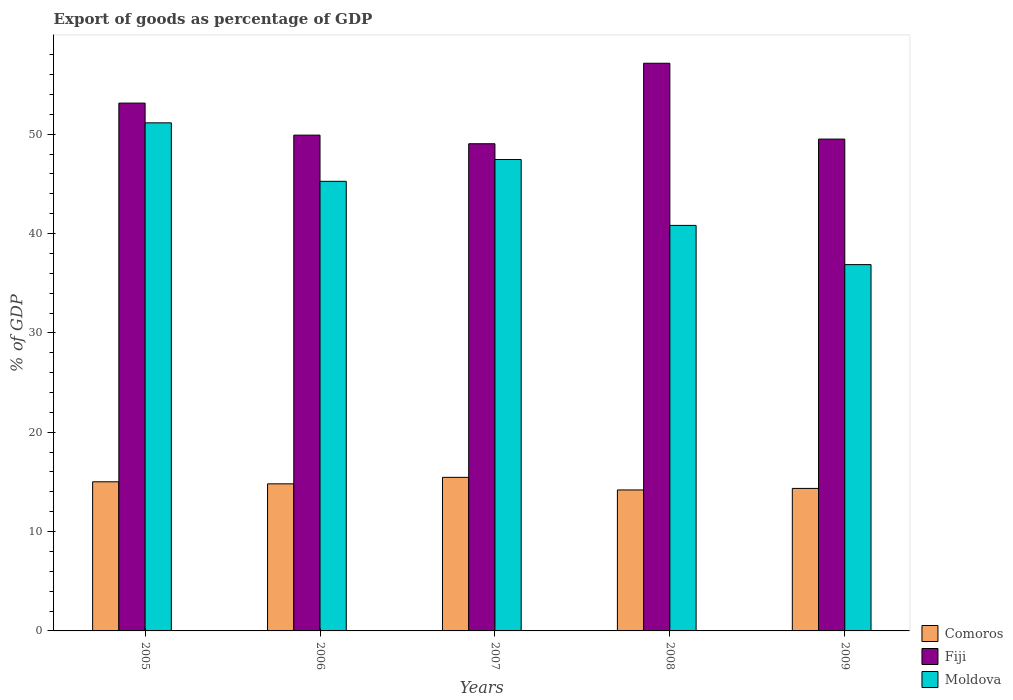Are the number of bars on each tick of the X-axis equal?
Your answer should be compact. Yes. How many bars are there on the 3rd tick from the left?
Keep it short and to the point. 3. How many bars are there on the 4th tick from the right?
Give a very brief answer. 3. What is the label of the 1st group of bars from the left?
Offer a very short reply. 2005. What is the export of goods as percentage of GDP in Moldova in 2006?
Give a very brief answer. 45.26. Across all years, what is the maximum export of goods as percentage of GDP in Comoros?
Provide a succinct answer. 15.46. Across all years, what is the minimum export of goods as percentage of GDP in Moldova?
Provide a short and direct response. 36.87. In which year was the export of goods as percentage of GDP in Moldova minimum?
Offer a very short reply. 2009. What is the total export of goods as percentage of GDP in Comoros in the graph?
Your answer should be compact. 73.81. What is the difference between the export of goods as percentage of GDP in Moldova in 2006 and that in 2009?
Your answer should be very brief. 8.38. What is the difference between the export of goods as percentage of GDP in Moldova in 2005 and the export of goods as percentage of GDP in Fiji in 2009?
Your answer should be very brief. 1.64. What is the average export of goods as percentage of GDP in Fiji per year?
Make the answer very short. 51.74. In the year 2005, what is the difference between the export of goods as percentage of GDP in Comoros and export of goods as percentage of GDP in Fiji?
Keep it short and to the point. -38.12. In how many years, is the export of goods as percentage of GDP in Moldova greater than 34 %?
Offer a very short reply. 5. What is the ratio of the export of goods as percentage of GDP in Comoros in 2007 to that in 2009?
Keep it short and to the point. 1.08. What is the difference between the highest and the second highest export of goods as percentage of GDP in Comoros?
Provide a short and direct response. 0.45. What is the difference between the highest and the lowest export of goods as percentage of GDP in Comoros?
Give a very brief answer. 1.27. In how many years, is the export of goods as percentage of GDP in Moldova greater than the average export of goods as percentage of GDP in Moldova taken over all years?
Keep it short and to the point. 3. Is the sum of the export of goods as percentage of GDP in Comoros in 2007 and 2009 greater than the maximum export of goods as percentage of GDP in Fiji across all years?
Provide a succinct answer. No. What does the 1st bar from the left in 2009 represents?
Offer a very short reply. Comoros. What does the 2nd bar from the right in 2007 represents?
Provide a succinct answer. Fiji. How many bars are there?
Offer a terse response. 15. Are all the bars in the graph horizontal?
Provide a short and direct response. No. How many years are there in the graph?
Offer a terse response. 5. What is the difference between two consecutive major ticks on the Y-axis?
Give a very brief answer. 10. Are the values on the major ticks of Y-axis written in scientific E-notation?
Make the answer very short. No. Does the graph contain any zero values?
Your response must be concise. No. How are the legend labels stacked?
Provide a succinct answer. Vertical. What is the title of the graph?
Provide a succinct answer. Export of goods as percentage of GDP. Does "United States" appear as one of the legend labels in the graph?
Give a very brief answer. No. What is the label or title of the Y-axis?
Your response must be concise. % of GDP. What is the % of GDP in Comoros in 2005?
Your answer should be very brief. 15.01. What is the % of GDP in Fiji in 2005?
Give a very brief answer. 53.13. What is the % of GDP of Moldova in 2005?
Ensure brevity in your answer.  51.14. What is the % of GDP in Comoros in 2006?
Your response must be concise. 14.8. What is the % of GDP of Fiji in 2006?
Provide a succinct answer. 49.91. What is the % of GDP in Moldova in 2006?
Offer a terse response. 45.26. What is the % of GDP in Comoros in 2007?
Offer a very short reply. 15.46. What is the % of GDP in Fiji in 2007?
Offer a terse response. 49.04. What is the % of GDP of Moldova in 2007?
Provide a succinct answer. 47.45. What is the % of GDP in Comoros in 2008?
Offer a terse response. 14.19. What is the % of GDP in Fiji in 2008?
Ensure brevity in your answer.  57.14. What is the % of GDP of Moldova in 2008?
Give a very brief answer. 40.82. What is the % of GDP in Comoros in 2009?
Your answer should be very brief. 14.34. What is the % of GDP of Fiji in 2009?
Your answer should be very brief. 49.51. What is the % of GDP in Moldova in 2009?
Your answer should be compact. 36.87. Across all years, what is the maximum % of GDP in Comoros?
Your answer should be very brief. 15.46. Across all years, what is the maximum % of GDP of Fiji?
Provide a short and direct response. 57.14. Across all years, what is the maximum % of GDP of Moldova?
Offer a terse response. 51.14. Across all years, what is the minimum % of GDP of Comoros?
Provide a short and direct response. 14.19. Across all years, what is the minimum % of GDP in Fiji?
Keep it short and to the point. 49.04. Across all years, what is the minimum % of GDP in Moldova?
Offer a very short reply. 36.87. What is the total % of GDP in Comoros in the graph?
Provide a short and direct response. 73.81. What is the total % of GDP in Fiji in the graph?
Provide a succinct answer. 258.72. What is the total % of GDP in Moldova in the graph?
Your answer should be very brief. 221.54. What is the difference between the % of GDP in Comoros in 2005 and that in 2006?
Your answer should be compact. 0.21. What is the difference between the % of GDP of Fiji in 2005 and that in 2006?
Provide a short and direct response. 3.23. What is the difference between the % of GDP of Moldova in 2005 and that in 2006?
Offer a very short reply. 5.89. What is the difference between the % of GDP of Comoros in 2005 and that in 2007?
Your answer should be very brief. -0.45. What is the difference between the % of GDP in Fiji in 2005 and that in 2007?
Keep it short and to the point. 4.09. What is the difference between the % of GDP of Moldova in 2005 and that in 2007?
Keep it short and to the point. 3.69. What is the difference between the % of GDP of Comoros in 2005 and that in 2008?
Your response must be concise. 0.82. What is the difference between the % of GDP in Fiji in 2005 and that in 2008?
Your response must be concise. -4.01. What is the difference between the % of GDP in Moldova in 2005 and that in 2008?
Offer a terse response. 10.33. What is the difference between the % of GDP in Comoros in 2005 and that in 2009?
Offer a terse response. 0.67. What is the difference between the % of GDP in Fiji in 2005 and that in 2009?
Offer a very short reply. 3.62. What is the difference between the % of GDP of Moldova in 2005 and that in 2009?
Offer a very short reply. 14.27. What is the difference between the % of GDP in Comoros in 2006 and that in 2007?
Your answer should be very brief. -0.65. What is the difference between the % of GDP of Fiji in 2006 and that in 2007?
Your answer should be compact. 0.87. What is the difference between the % of GDP in Moldova in 2006 and that in 2007?
Keep it short and to the point. -2.2. What is the difference between the % of GDP in Comoros in 2006 and that in 2008?
Keep it short and to the point. 0.61. What is the difference between the % of GDP in Fiji in 2006 and that in 2008?
Provide a short and direct response. -7.24. What is the difference between the % of GDP in Moldova in 2006 and that in 2008?
Keep it short and to the point. 4.44. What is the difference between the % of GDP in Comoros in 2006 and that in 2009?
Make the answer very short. 0.46. What is the difference between the % of GDP in Fiji in 2006 and that in 2009?
Give a very brief answer. 0.4. What is the difference between the % of GDP of Moldova in 2006 and that in 2009?
Ensure brevity in your answer.  8.38. What is the difference between the % of GDP in Comoros in 2007 and that in 2008?
Your answer should be very brief. 1.27. What is the difference between the % of GDP of Fiji in 2007 and that in 2008?
Your answer should be very brief. -8.1. What is the difference between the % of GDP in Moldova in 2007 and that in 2008?
Offer a very short reply. 6.63. What is the difference between the % of GDP of Comoros in 2007 and that in 2009?
Your answer should be very brief. 1.11. What is the difference between the % of GDP of Fiji in 2007 and that in 2009?
Make the answer very short. -0.47. What is the difference between the % of GDP of Moldova in 2007 and that in 2009?
Provide a succinct answer. 10.58. What is the difference between the % of GDP in Comoros in 2008 and that in 2009?
Your answer should be very brief. -0.15. What is the difference between the % of GDP of Fiji in 2008 and that in 2009?
Your answer should be very brief. 7.63. What is the difference between the % of GDP of Moldova in 2008 and that in 2009?
Ensure brevity in your answer.  3.95. What is the difference between the % of GDP of Comoros in 2005 and the % of GDP of Fiji in 2006?
Provide a short and direct response. -34.89. What is the difference between the % of GDP of Comoros in 2005 and the % of GDP of Moldova in 2006?
Keep it short and to the point. -30.24. What is the difference between the % of GDP of Fiji in 2005 and the % of GDP of Moldova in 2006?
Your answer should be compact. 7.87. What is the difference between the % of GDP of Comoros in 2005 and the % of GDP of Fiji in 2007?
Offer a terse response. -34.03. What is the difference between the % of GDP in Comoros in 2005 and the % of GDP in Moldova in 2007?
Keep it short and to the point. -32.44. What is the difference between the % of GDP in Fiji in 2005 and the % of GDP in Moldova in 2007?
Ensure brevity in your answer.  5.68. What is the difference between the % of GDP of Comoros in 2005 and the % of GDP of Fiji in 2008?
Offer a terse response. -42.13. What is the difference between the % of GDP of Comoros in 2005 and the % of GDP of Moldova in 2008?
Provide a short and direct response. -25.81. What is the difference between the % of GDP in Fiji in 2005 and the % of GDP in Moldova in 2008?
Your response must be concise. 12.31. What is the difference between the % of GDP of Comoros in 2005 and the % of GDP of Fiji in 2009?
Provide a succinct answer. -34.49. What is the difference between the % of GDP in Comoros in 2005 and the % of GDP in Moldova in 2009?
Your response must be concise. -21.86. What is the difference between the % of GDP in Fiji in 2005 and the % of GDP in Moldova in 2009?
Provide a succinct answer. 16.26. What is the difference between the % of GDP of Comoros in 2006 and the % of GDP of Fiji in 2007?
Provide a short and direct response. -34.23. What is the difference between the % of GDP of Comoros in 2006 and the % of GDP of Moldova in 2007?
Provide a short and direct response. -32.65. What is the difference between the % of GDP of Fiji in 2006 and the % of GDP of Moldova in 2007?
Offer a very short reply. 2.45. What is the difference between the % of GDP of Comoros in 2006 and the % of GDP of Fiji in 2008?
Make the answer very short. -42.34. What is the difference between the % of GDP in Comoros in 2006 and the % of GDP in Moldova in 2008?
Your answer should be very brief. -26.01. What is the difference between the % of GDP of Fiji in 2006 and the % of GDP of Moldova in 2008?
Provide a short and direct response. 9.09. What is the difference between the % of GDP in Comoros in 2006 and the % of GDP in Fiji in 2009?
Provide a succinct answer. -34.7. What is the difference between the % of GDP of Comoros in 2006 and the % of GDP of Moldova in 2009?
Your answer should be compact. -22.07. What is the difference between the % of GDP in Fiji in 2006 and the % of GDP in Moldova in 2009?
Your answer should be very brief. 13.03. What is the difference between the % of GDP in Comoros in 2007 and the % of GDP in Fiji in 2008?
Provide a succinct answer. -41.68. What is the difference between the % of GDP in Comoros in 2007 and the % of GDP in Moldova in 2008?
Keep it short and to the point. -25.36. What is the difference between the % of GDP of Fiji in 2007 and the % of GDP of Moldova in 2008?
Your answer should be compact. 8.22. What is the difference between the % of GDP in Comoros in 2007 and the % of GDP in Fiji in 2009?
Keep it short and to the point. -34.05. What is the difference between the % of GDP in Comoros in 2007 and the % of GDP in Moldova in 2009?
Provide a short and direct response. -21.41. What is the difference between the % of GDP of Fiji in 2007 and the % of GDP of Moldova in 2009?
Provide a succinct answer. 12.17. What is the difference between the % of GDP of Comoros in 2008 and the % of GDP of Fiji in 2009?
Your response must be concise. -35.32. What is the difference between the % of GDP of Comoros in 2008 and the % of GDP of Moldova in 2009?
Your response must be concise. -22.68. What is the difference between the % of GDP of Fiji in 2008 and the % of GDP of Moldova in 2009?
Keep it short and to the point. 20.27. What is the average % of GDP of Comoros per year?
Keep it short and to the point. 14.76. What is the average % of GDP in Fiji per year?
Provide a short and direct response. 51.74. What is the average % of GDP of Moldova per year?
Give a very brief answer. 44.31. In the year 2005, what is the difference between the % of GDP in Comoros and % of GDP in Fiji?
Keep it short and to the point. -38.12. In the year 2005, what is the difference between the % of GDP in Comoros and % of GDP in Moldova?
Offer a very short reply. -36.13. In the year 2005, what is the difference between the % of GDP in Fiji and % of GDP in Moldova?
Ensure brevity in your answer.  1.99. In the year 2006, what is the difference between the % of GDP of Comoros and % of GDP of Fiji?
Keep it short and to the point. -35.1. In the year 2006, what is the difference between the % of GDP of Comoros and % of GDP of Moldova?
Provide a short and direct response. -30.45. In the year 2006, what is the difference between the % of GDP in Fiji and % of GDP in Moldova?
Provide a succinct answer. 4.65. In the year 2007, what is the difference between the % of GDP in Comoros and % of GDP in Fiji?
Keep it short and to the point. -33.58. In the year 2007, what is the difference between the % of GDP in Comoros and % of GDP in Moldova?
Provide a succinct answer. -31.99. In the year 2007, what is the difference between the % of GDP of Fiji and % of GDP of Moldova?
Provide a succinct answer. 1.59. In the year 2008, what is the difference between the % of GDP in Comoros and % of GDP in Fiji?
Offer a very short reply. -42.95. In the year 2008, what is the difference between the % of GDP in Comoros and % of GDP in Moldova?
Provide a succinct answer. -26.63. In the year 2008, what is the difference between the % of GDP in Fiji and % of GDP in Moldova?
Ensure brevity in your answer.  16.32. In the year 2009, what is the difference between the % of GDP in Comoros and % of GDP in Fiji?
Your answer should be very brief. -35.16. In the year 2009, what is the difference between the % of GDP of Comoros and % of GDP of Moldova?
Offer a very short reply. -22.53. In the year 2009, what is the difference between the % of GDP of Fiji and % of GDP of Moldova?
Your answer should be compact. 12.64. What is the ratio of the % of GDP in Fiji in 2005 to that in 2006?
Offer a terse response. 1.06. What is the ratio of the % of GDP of Moldova in 2005 to that in 2006?
Offer a terse response. 1.13. What is the ratio of the % of GDP in Comoros in 2005 to that in 2007?
Your response must be concise. 0.97. What is the ratio of the % of GDP in Fiji in 2005 to that in 2007?
Your response must be concise. 1.08. What is the ratio of the % of GDP of Moldova in 2005 to that in 2007?
Provide a succinct answer. 1.08. What is the ratio of the % of GDP of Comoros in 2005 to that in 2008?
Ensure brevity in your answer.  1.06. What is the ratio of the % of GDP of Fiji in 2005 to that in 2008?
Give a very brief answer. 0.93. What is the ratio of the % of GDP in Moldova in 2005 to that in 2008?
Your response must be concise. 1.25. What is the ratio of the % of GDP in Comoros in 2005 to that in 2009?
Keep it short and to the point. 1.05. What is the ratio of the % of GDP in Fiji in 2005 to that in 2009?
Provide a short and direct response. 1.07. What is the ratio of the % of GDP in Moldova in 2005 to that in 2009?
Your answer should be compact. 1.39. What is the ratio of the % of GDP in Comoros in 2006 to that in 2007?
Give a very brief answer. 0.96. What is the ratio of the % of GDP of Fiji in 2006 to that in 2007?
Provide a succinct answer. 1.02. What is the ratio of the % of GDP in Moldova in 2006 to that in 2007?
Offer a very short reply. 0.95. What is the ratio of the % of GDP of Comoros in 2006 to that in 2008?
Ensure brevity in your answer.  1.04. What is the ratio of the % of GDP of Fiji in 2006 to that in 2008?
Your answer should be very brief. 0.87. What is the ratio of the % of GDP of Moldova in 2006 to that in 2008?
Your answer should be compact. 1.11. What is the ratio of the % of GDP in Comoros in 2006 to that in 2009?
Give a very brief answer. 1.03. What is the ratio of the % of GDP in Fiji in 2006 to that in 2009?
Give a very brief answer. 1.01. What is the ratio of the % of GDP in Moldova in 2006 to that in 2009?
Give a very brief answer. 1.23. What is the ratio of the % of GDP of Comoros in 2007 to that in 2008?
Give a very brief answer. 1.09. What is the ratio of the % of GDP of Fiji in 2007 to that in 2008?
Keep it short and to the point. 0.86. What is the ratio of the % of GDP in Moldova in 2007 to that in 2008?
Ensure brevity in your answer.  1.16. What is the ratio of the % of GDP in Comoros in 2007 to that in 2009?
Your response must be concise. 1.08. What is the ratio of the % of GDP in Fiji in 2007 to that in 2009?
Keep it short and to the point. 0.99. What is the ratio of the % of GDP of Moldova in 2007 to that in 2009?
Make the answer very short. 1.29. What is the ratio of the % of GDP of Comoros in 2008 to that in 2009?
Give a very brief answer. 0.99. What is the ratio of the % of GDP of Fiji in 2008 to that in 2009?
Your response must be concise. 1.15. What is the ratio of the % of GDP in Moldova in 2008 to that in 2009?
Offer a very short reply. 1.11. What is the difference between the highest and the second highest % of GDP of Comoros?
Your answer should be compact. 0.45. What is the difference between the highest and the second highest % of GDP in Fiji?
Your answer should be very brief. 4.01. What is the difference between the highest and the second highest % of GDP in Moldova?
Make the answer very short. 3.69. What is the difference between the highest and the lowest % of GDP of Comoros?
Your answer should be compact. 1.27. What is the difference between the highest and the lowest % of GDP of Fiji?
Make the answer very short. 8.1. What is the difference between the highest and the lowest % of GDP of Moldova?
Keep it short and to the point. 14.27. 